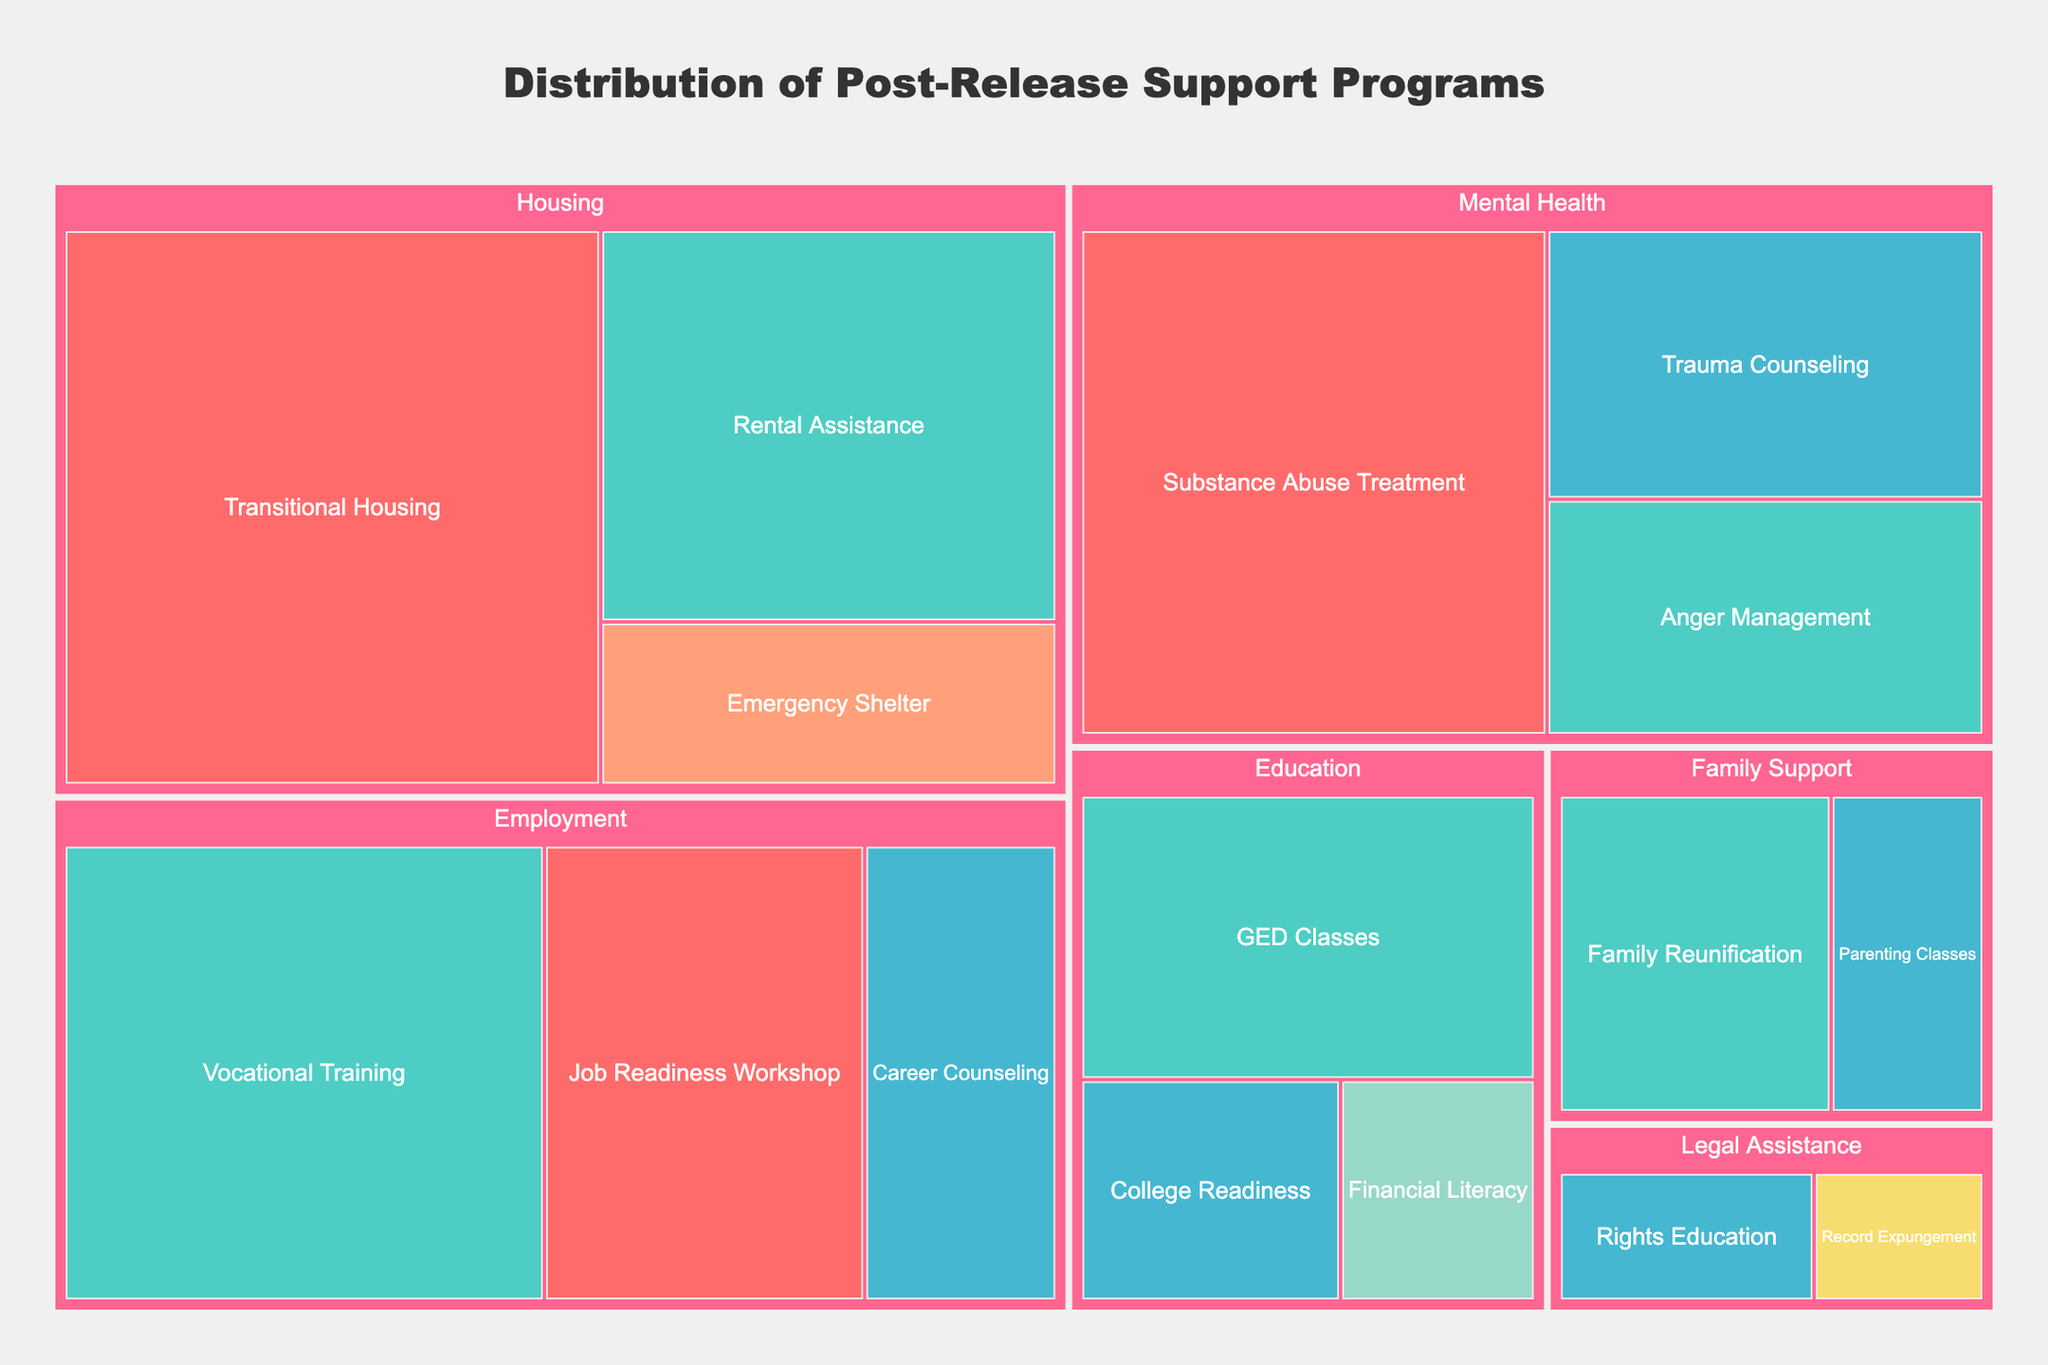What is the title of the Treemap? The title is usually displayed at the top of the figure. In this case, it reads "Distribution of Post-Release Support Programs".
Answer: Distribution of Post-Release Support Programs Which category has the highest budget allocation? By examining the size of the rectangles in the Treemap, we see that the largest rectangle belongs to the "Housing" category, implying it has the highest budget allocation.
Answer: Housing What program has the smallest budget in the "Legal Assistance" category? The "Legal Assistance" category has two programs. By looking at the sizes, "Record Expungement" has the smallest budget compared to "Rights Education".
Answer: Record Expungement Which funding source is responsible for the "Job Readiness Workshop" program? By identifying the "Job Readiness Workshop" program and looking at its color, we can match it to the corresponding funding source. This program is colored according to the "Federal Grant" funding.
Answer: Federal Grant How does the budget of "Substance Abuse Treatment" compare to "Trauma Counseling"? "Substance Abuse Treatment" is part of the "Mental Health" category and has a larger rectangle than "Trauma Counseling". Therefore, "Substance Abuse Treatment" has a higher budget.
Answer: Substance Abuse Treatment has a higher budget What's the total budget for all employment-related programs combined? The employment-related programs are "Job Readiness Workshop", "Vocational Training", and "Career Counseling". Summing their budgets gives us 500,000 + 750,000 + 300,000 = 1,550,000.
Answer: 1,550,000 What is the most funded program overall? By identifying the largest rectangle in the entire Treemap, we see that "Transitional Housing" has the largest budget, making it the most funded program.
Answer: Transitional Housing Which funding source has the most budget allocation and what’s the total amount? To find the funding source with the most budget allocation, we sum the budgets of programs under each source. Federal Grant: 500,000 + 1,000,000 + 800,000 = 2,300,000; State Government: 750,000 + 600,000 + 350,000 + 450,000 + 320,000 = 2,470,000; Non-Profit: 300,000 + 400,000 + 200,000 + 180,000 + 150,000 = 1,230,000. Therefore, State Government has the most budget allocation totaling 2,470,000.
Answer: State Government, 2,470,000 What category has funding from "Corporate Sponsorship" and how much is it? By searching the Treemap for the color representing Corporate Sponsorship, we see it falls under the "Education" category with a budget of 150,000.
Answer: Education, 150,000 How does the budget for "Anger Management" compare to "Financial Literacy"? "Anger Management" in the "Mental Health" category has a budget of 350,000, while "Financial Literacy" in the "Education" category has 150,000. Hence, "Anger Management" has a higher budget.
Answer: Anger Management has a higher budget 